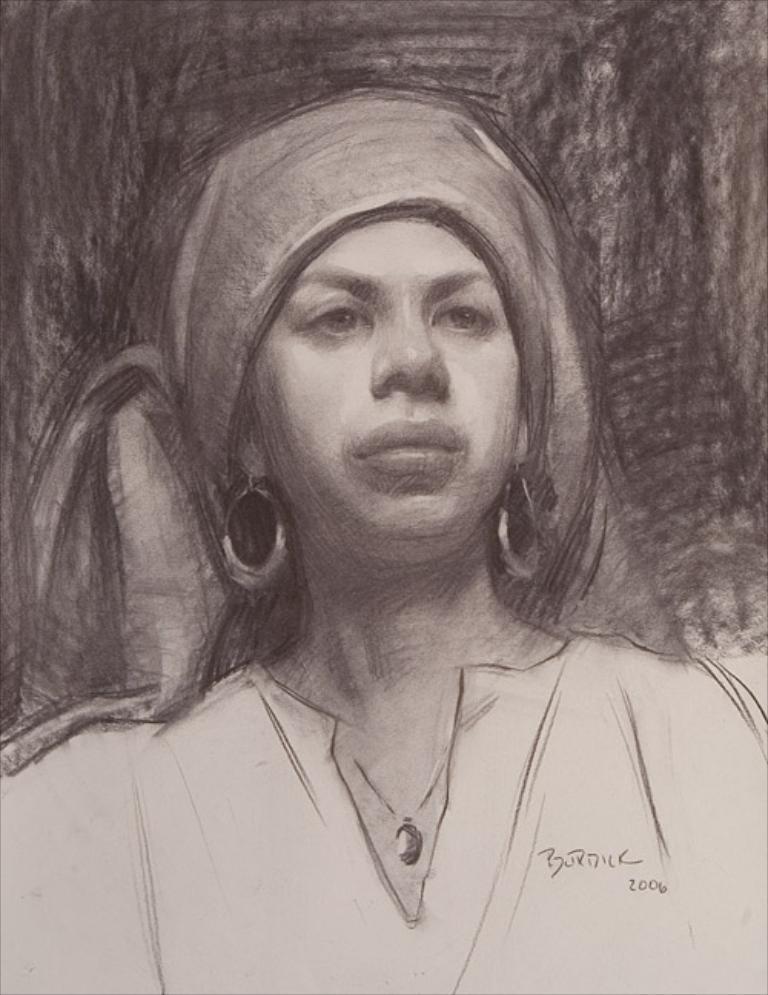How would you summarize this image in a sentence or two? This image is a painting. In this painting we can see a lady. She is wearing a headscarf. 